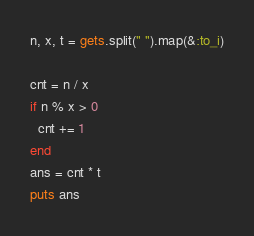Convert code to text. <code><loc_0><loc_0><loc_500><loc_500><_Ruby_>n, x, t = gets.split(" ").map(&:to_i)

cnt = n / x
if n % x > 0
  cnt += 1 
end
ans = cnt * t
puts ans</code> 